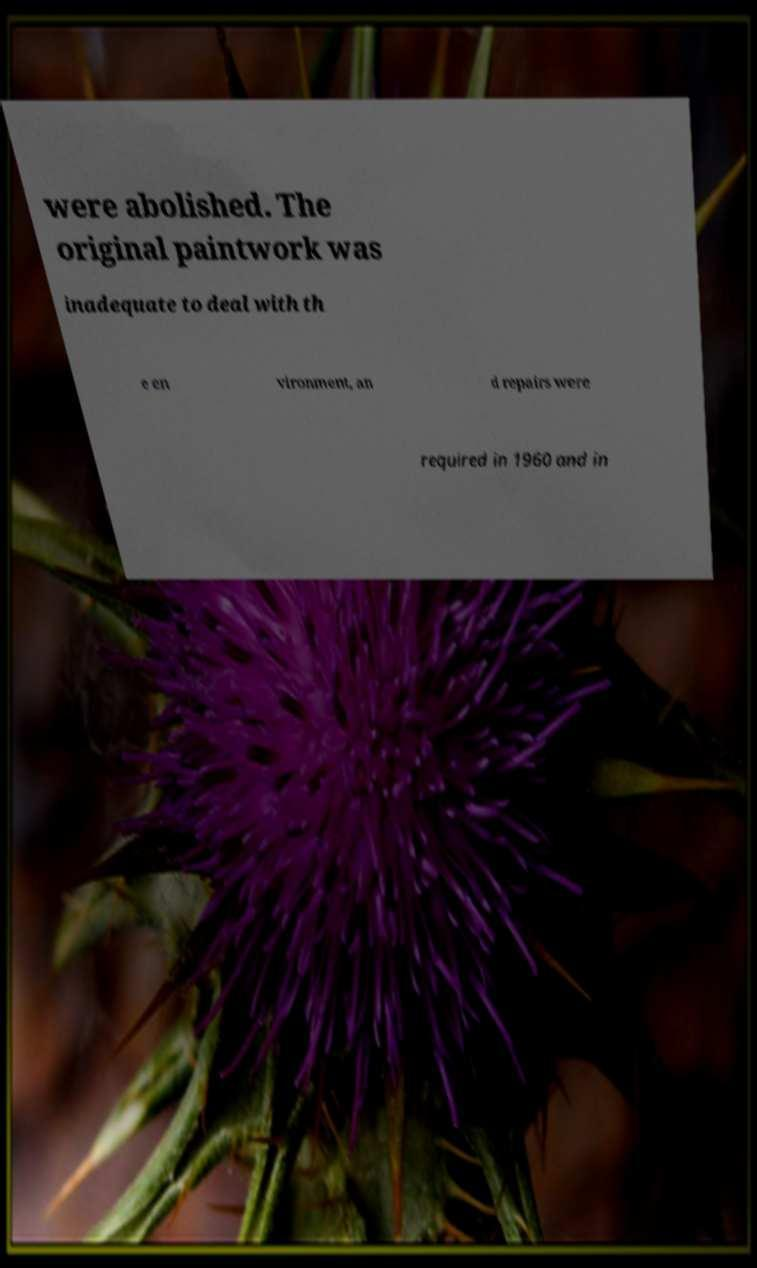Could you extract and type out the text from this image? were abolished. The original paintwork was inadequate to deal with th e en vironment, an d repairs were required in 1960 and in 